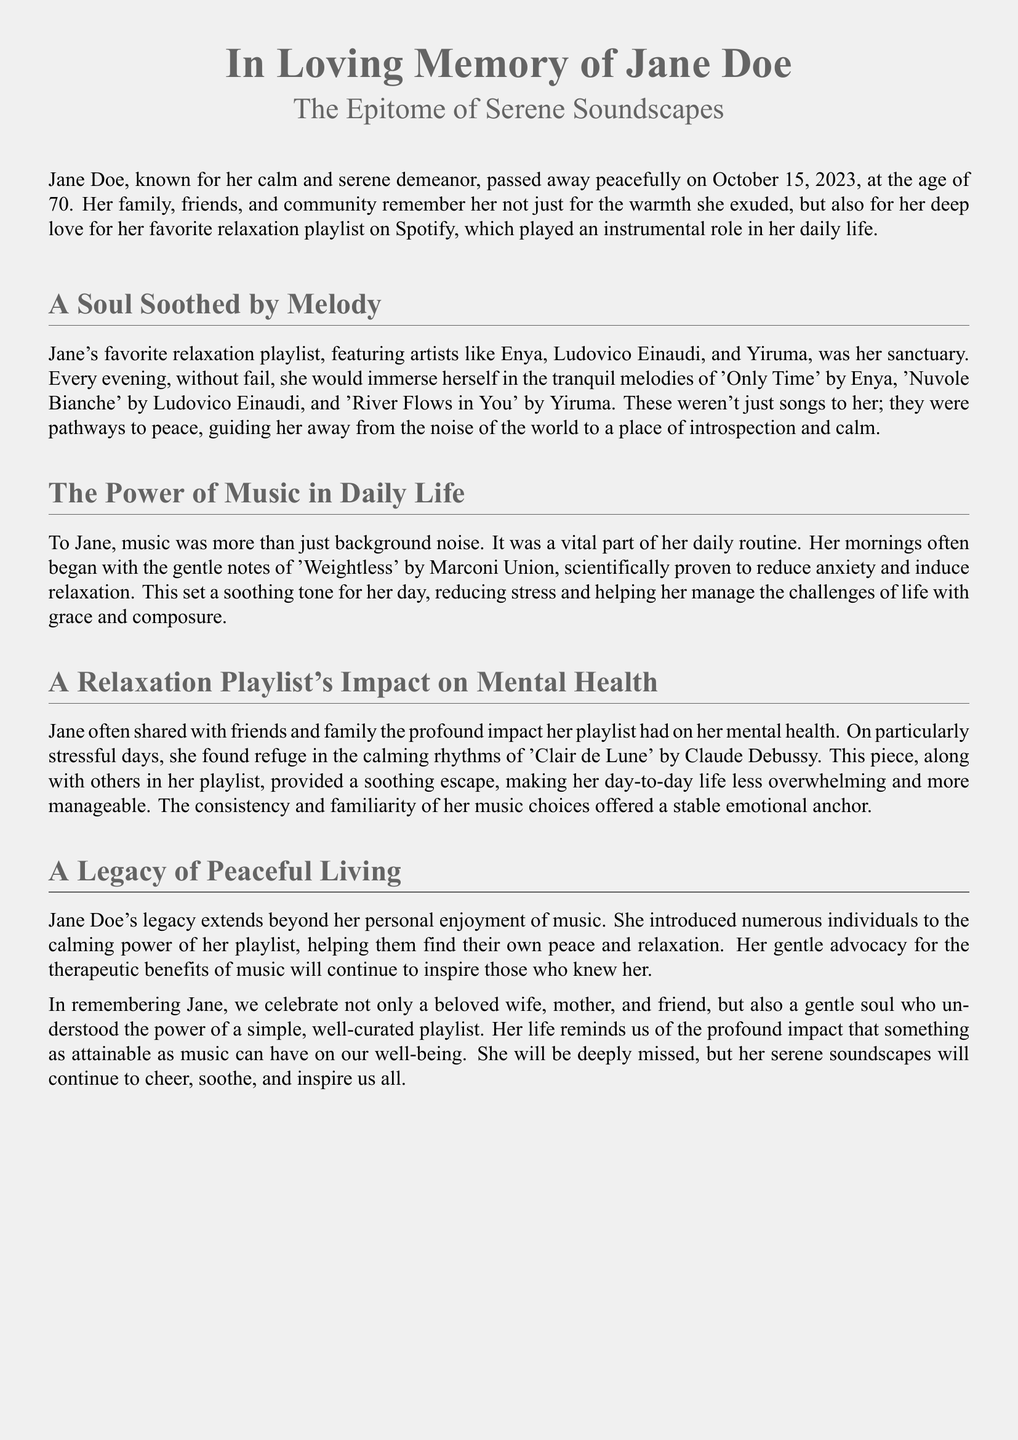what is the name of the person being remembered? The document is an obituary for Jane Doe, who is being remembered.
Answer: Jane Doe what was Jane's age at the time of passing? The document states that Jane passed away at the age of 70.
Answer: 70 which artist's song is mentioned as part of Jane's favorite relaxation playlist? The document mentions that artists like Enya, Ludovico Einaudi, and Yiruma are featured in her playlist.
Answer: Enya what is the title of the piece by Claude Debussy mentioned in the document? The document refers to 'Clair de Lune' as a piece that had a calming effect on Jane.
Answer: Clair de Lune how did Jane start her mornings? The document describes that Jane often began her mornings with the gentle notes of 'Weightless' by Marconi Union.
Answer: 'Weightless' what effect did Jane say music had on her mental health? The document indicates that Jane shared the profound impact her playlist had on her mental health, particularly in providing a calming escape.
Answer: Calming escape what legacy did Jane leave regarding her relaxation playlist? The document notes that Jane’s legacy extends to introducing others to the calming power of her playlist.
Answer: Calming power on what date did Jane pass away? According to the document, Jane passed away on October 15, 2023.
Answer: October 15, 2023 what is highlighted as a theme in Jane's life through the playlist? The document mentions that Jane understood the power of a simple, well-curated playlist.
Answer: Well-curated playlist 